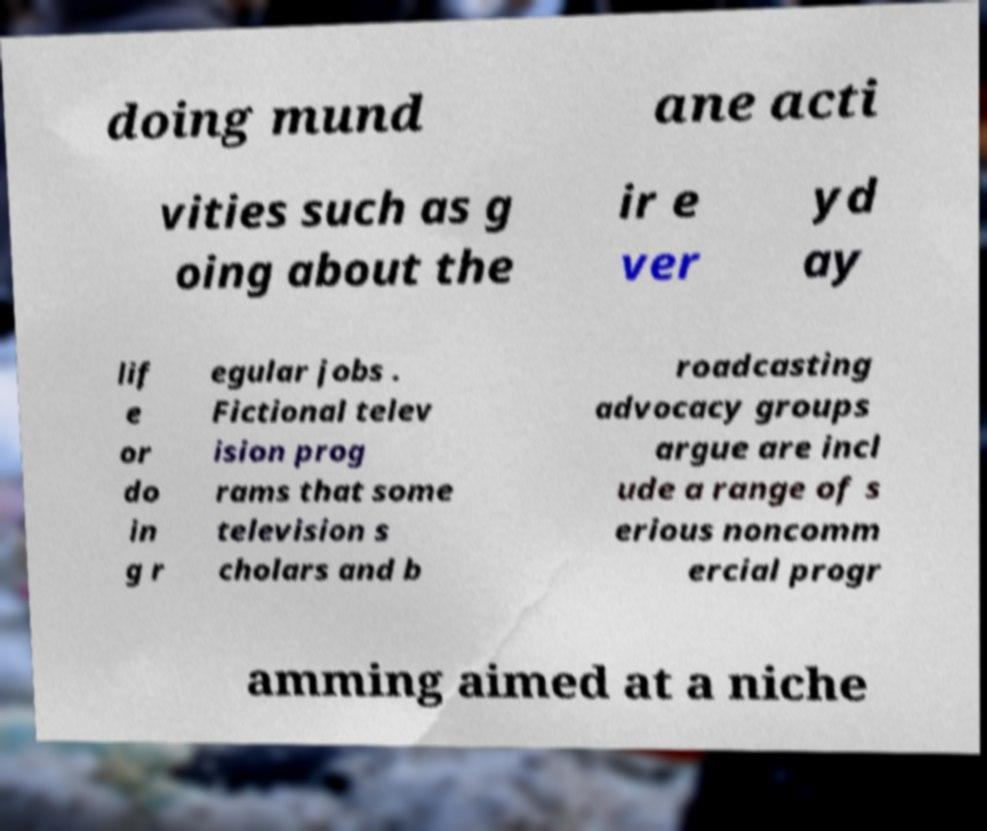Can you accurately transcribe the text from the provided image for me? doing mund ane acti vities such as g oing about the ir e ver yd ay lif e or do in g r egular jobs . Fictional telev ision prog rams that some television s cholars and b roadcasting advocacy groups argue are incl ude a range of s erious noncomm ercial progr amming aimed at a niche 